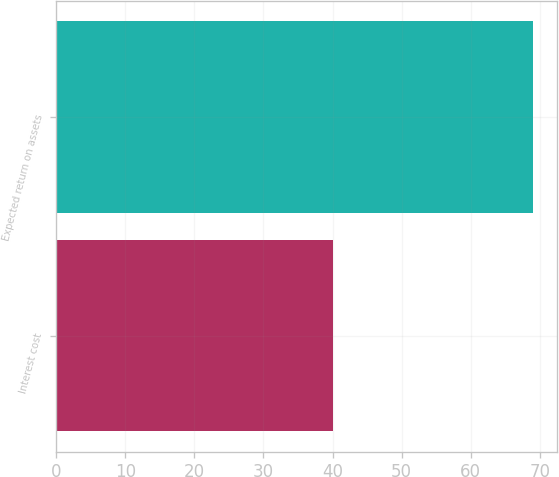<chart> <loc_0><loc_0><loc_500><loc_500><bar_chart><fcel>Interest cost<fcel>Expected return on assets<nl><fcel>40<fcel>69<nl></chart> 